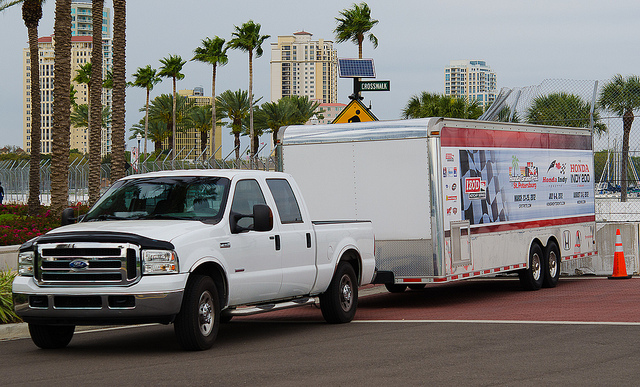Please transcribe the text in this image. HONDA ND1200 